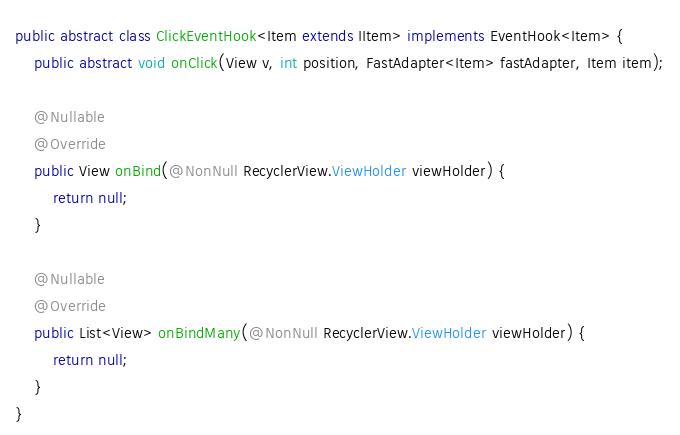Convert code to text. <code><loc_0><loc_0><loc_500><loc_500><_Java_>public abstract class ClickEventHook<Item extends IItem> implements EventHook<Item> {
    public abstract void onClick(View v, int position, FastAdapter<Item> fastAdapter, Item item);

    @Nullable
    @Override
    public View onBind(@NonNull RecyclerView.ViewHolder viewHolder) {
        return null;
    }

    @Nullable
    @Override
    public List<View> onBindMany(@NonNull RecyclerView.ViewHolder viewHolder) {
        return null;
    }
}</code> 